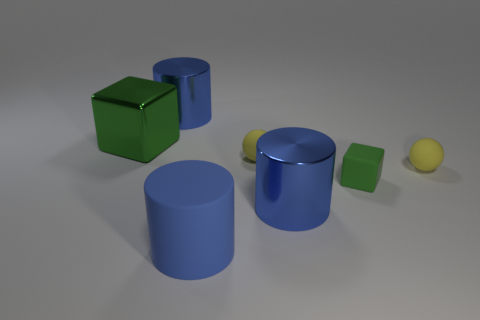Add 2 green shiny blocks. How many objects exist? 9 Subtract all cylinders. How many objects are left? 4 Add 4 tiny yellow rubber balls. How many tiny yellow rubber balls are left? 6 Add 6 yellow spheres. How many yellow spheres exist? 8 Subtract 0 cyan spheres. How many objects are left? 7 Subtract all large green metal blocks. Subtract all big rubber cylinders. How many objects are left? 5 